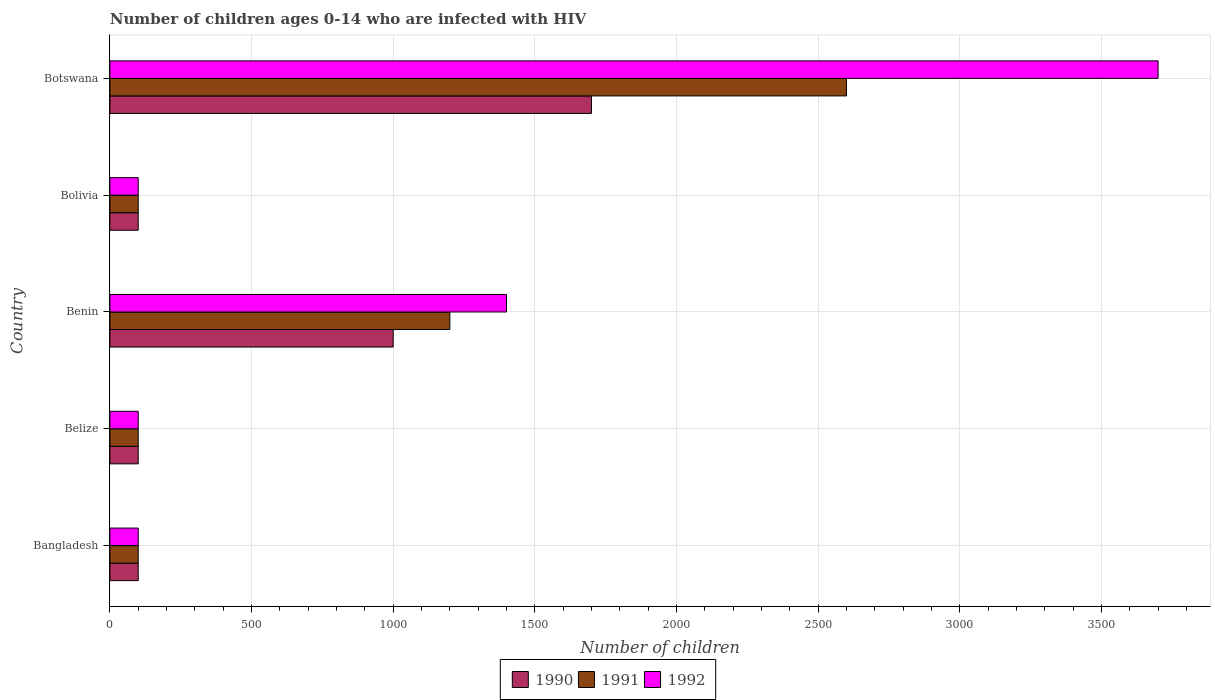How many bars are there on the 4th tick from the top?
Your response must be concise. 3. What is the number of HIV infected children in 1992 in Belize?
Your response must be concise. 100. Across all countries, what is the maximum number of HIV infected children in 1992?
Provide a succinct answer. 3700. Across all countries, what is the minimum number of HIV infected children in 1992?
Ensure brevity in your answer.  100. In which country was the number of HIV infected children in 1992 maximum?
Provide a short and direct response. Botswana. In which country was the number of HIV infected children in 1991 minimum?
Your answer should be very brief. Bangladesh. What is the total number of HIV infected children in 1991 in the graph?
Your answer should be compact. 4100. What is the difference between the number of HIV infected children in 1992 in Bolivia and that in Botswana?
Offer a terse response. -3600. What is the difference between the number of HIV infected children in 1990 in Bangladesh and the number of HIV infected children in 1992 in Belize?
Offer a terse response. 0. What is the average number of HIV infected children in 1990 per country?
Offer a terse response. 600. In how many countries, is the number of HIV infected children in 1990 greater than 2900 ?
Keep it short and to the point. 0. What is the ratio of the number of HIV infected children in 1991 in Belize to that in Benin?
Offer a very short reply. 0.08. Is the difference between the number of HIV infected children in 1990 in Belize and Botswana greater than the difference between the number of HIV infected children in 1991 in Belize and Botswana?
Provide a succinct answer. Yes. What is the difference between the highest and the second highest number of HIV infected children in 1990?
Your answer should be compact. 700. What is the difference between the highest and the lowest number of HIV infected children in 1992?
Provide a short and direct response. 3600. Is the sum of the number of HIV infected children in 1991 in Bangladesh and Bolivia greater than the maximum number of HIV infected children in 1990 across all countries?
Give a very brief answer. No. What does the 1st bar from the bottom in Botswana represents?
Keep it short and to the point. 1990. Is it the case that in every country, the sum of the number of HIV infected children in 1992 and number of HIV infected children in 1990 is greater than the number of HIV infected children in 1991?
Give a very brief answer. Yes. How many bars are there?
Your answer should be compact. 15. What is the difference between two consecutive major ticks on the X-axis?
Give a very brief answer. 500. Where does the legend appear in the graph?
Provide a succinct answer. Bottom center. What is the title of the graph?
Ensure brevity in your answer.  Number of children ages 0-14 who are infected with HIV. Does "1981" appear as one of the legend labels in the graph?
Your answer should be compact. No. What is the label or title of the X-axis?
Give a very brief answer. Number of children. What is the label or title of the Y-axis?
Offer a very short reply. Country. What is the Number of children of 1991 in Belize?
Give a very brief answer. 100. What is the Number of children of 1992 in Belize?
Provide a succinct answer. 100. What is the Number of children in 1990 in Benin?
Your answer should be very brief. 1000. What is the Number of children of 1991 in Benin?
Offer a terse response. 1200. What is the Number of children in 1992 in Benin?
Your answer should be very brief. 1400. What is the Number of children in 1990 in Botswana?
Ensure brevity in your answer.  1700. What is the Number of children in 1991 in Botswana?
Your response must be concise. 2600. What is the Number of children in 1992 in Botswana?
Make the answer very short. 3700. Across all countries, what is the maximum Number of children in 1990?
Your answer should be very brief. 1700. Across all countries, what is the maximum Number of children of 1991?
Offer a very short reply. 2600. Across all countries, what is the maximum Number of children in 1992?
Your answer should be very brief. 3700. Across all countries, what is the minimum Number of children in 1990?
Provide a short and direct response. 100. Across all countries, what is the minimum Number of children of 1991?
Ensure brevity in your answer.  100. Across all countries, what is the minimum Number of children in 1992?
Give a very brief answer. 100. What is the total Number of children in 1990 in the graph?
Make the answer very short. 3000. What is the total Number of children in 1991 in the graph?
Provide a succinct answer. 4100. What is the total Number of children of 1992 in the graph?
Provide a succinct answer. 5400. What is the difference between the Number of children in 1991 in Bangladesh and that in Belize?
Your response must be concise. 0. What is the difference between the Number of children in 1990 in Bangladesh and that in Benin?
Ensure brevity in your answer.  -900. What is the difference between the Number of children in 1991 in Bangladesh and that in Benin?
Ensure brevity in your answer.  -1100. What is the difference between the Number of children in 1992 in Bangladesh and that in Benin?
Your response must be concise. -1300. What is the difference between the Number of children in 1992 in Bangladesh and that in Bolivia?
Ensure brevity in your answer.  0. What is the difference between the Number of children in 1990 in Bangladesh and that in Botswana?
Offer a terse response. -1600. What is the difference between the Number of children in 1991 in Bangladesh and that in Botswana?
Provide a succinct answer. -2500. What is the difference between the Number of children in 1992 in Bangladesh and that in Botswana?
Your answer should be very brief. -3600. What is the difference between the Number of children of 1990 in Belize and that in Benin?
Provide a short and direct response. -900. What is the difference between the Number of children in 1991 in Belize and that in Benin?
Your answer should be very brief. -1100. What is the difference between the Number of children in 1992 in Belize and that in Benin?
Give a very brief answer. -1300. What is the difference between the Number of children of 1992 in Belize and that in Bolivia?
Your answer should be compact. 0. What is the difference between the Number of children in 1990 in Belize and that in Botswana?
Provide a succinct answer. -1600. What is the difference between the Number of children in 1991 in Belize and that in Botswana?
Make the answer very short. -2500. What is the difference between the Number of children in 1992 in Belize and that in Botswana?
Ensure brevity in your answer.  -3600. What is the difference between the Number of children in 1990 in Benin and that in Bolivia?
Your answer should be compact. 900. What is the difference between the Number of children in 1991 in Benin and that in Bolivia?
Give a very brief answer. 1100. What is the difference between the Number of children of 1992 in Benin and that in Bolivia?
Your response must be concise. 1300. What is the difference between the Number of children of 1990 in Benin and that in Botswana?
Provide a short and direct response. -700. What is the difference between the Number of children of 1991 in Benin and that in Botswana?
Give a very brief answer. -1400. What is the difference between the Number of children in 1992 in Benin and that in Botswana?
Offer a very short reply. -2300. What is the difference between the Number of children of 1990 in Bolivia and that in Botswana?
Your response must be concise. -1600. What is the difference between the Number of children in 1991 in Bolivia and that in Botswana?
Ensure brevity in your answer.  -2500. What is the difference between the Number of children in 1992 in Bolivia and that in Botswana?
Your response must be concise. -3600. What is the difference between the Number of children of 1990 in Bangladesh and the Number of children of 1991 in Belize?
Give a very brief answer. 0. What is the difference between the Number of children of 1990 in Bangladesh and the Number of children of 1991 in Benin?
Offer a terse response. -1100. What is the difference between the Number of children in 1990 in Bangladesh and the Number of children in 1992 in Benin?
Offer a terse response. -1300. What is the difference between the Number of children in 1991 in Bangladesh and the Number of children in 1992 in Benin?
Give a very brief answer. -1300. What is the difference between the Number of children of 1990 in Bangladesh and the Number of children of 1991 in Bolivia?
Ensure brevity in your answer.  0. What is the difference between the Number of children of 1990 in Bangladesh and the Number of children of 1992 in Bolivia?
Your answer should be compact. 0. What is the difference between the Number of children of 1990 in Bangladesh and the Number of children of 1991 in Botswana?
Your answer should be very brief. -2500. What is the difference between the Number of children of 1990 in Bangladesh and the Number of children of 1992 in Botswana?
Give a very brief answer. -3600. What is the difference between the Number of children of 1991 in Bangladesh and the Number of children of 1992 in Botswana?
Your answer should be very brief. -3600. What is the difference between the Number of children in 1990 in Belize and the Number of children in 1991 in Benin?
Ensure brevity in your answer.  -1100. What is the difference between the Number of children in 1990 in Belize and the Number of children in 1992 in Benin?
Your answer should be very brief. -1300. What is the difference between the Number of children in 1991 in Belize and the Number of children in 1992 in Benin?
Give a very brief answer. -1300. What is the difference between the Number of children of 1990 in Belize and the Number of children of 1991 in Bolivia?
Make the answer very short. 0. What is the difference between the Number of children of 1991 in Belize and the Number of children of 1992 in Bolivia?
Provide a short and direct response. 0. What is the difference between the Number of children in 1990 in Belize and the Number of children in 1991 in Botswana?
Offer a very short reply. -2500. What is the difference between the Number of children in 1990 in Belize and the Number of children in 1992 in Botswana?
Give a very brief answer. -3600. What is the difference between the Number of children of 1991 in Belize and the Number of children of 1992 in Botswana?
Keep it short and to the point. -3600. What is the difference between the Number of children in 1990 in Benin and the Number of children in 1991 in Bolivia?
Provide a short and direct response. 900. What is the difference between the Number of children in 1990 in Benin and the Number of children in 1992 in Bolivia?
Make the answer very short. 900. What is the difference between the Number of children of 1991 in Benin and the Number of children of 1992 in Bolivia?
Your answer should be very brief. 1100. What is the difference between the Number of children of 1990 in Benin and the Number of children of 1991 in Botswana?
Provide a succinct answer. -1600. What is the difference between the Number of children of 1990 in Benin and the Number of children of 1992 in Botswana?
Your response must be concise. -2700. What is the difference between the Number of children of 1991 in Benin and the Number of children of 1992 in Botswana?
Your response must be concise. -2500. What is the difference between the Number of children in 1990 in Bolivia and the Number of children in 1991 in Botswana?
Give a very brief answer. -2500. What is the difference between the Number of children of 1990 in Bolivia and the Number of children of 1992 in Botswana?
Your answer should be very brief. -3600. What is the difference between the Number of children in 1991 in Bolivia and the Number of children in 1992 in Botswana?
Ensure brevity in your answer.  -3600. What is the average Number of children in 1990 per country?
Give a very brief answer. 600. What is the average Number of children in 1991 per country?
Offer a very short reply. 820. What is the average Number of children of 1992 per country?
Give a very brief answer. 1080. What is the difference between the Number of children in 1990 and Number of children in 1992 in Bangladesh?
Provide a short and direct response. 0. What is the difference between the Number of children of 1991 and Number of children of 1992 in Bangladesh?
Your answer should be compact. 0. What is the difference between the Number of children in 1990 and Number of children in 1991 in Belize?
Provide a succinct answer. 0. What is the difference between the Number of children of 1990 and Number of children of 1992 in Belize?
Offer a very short reply. 0. What is the difference between the Number of children of 1991 and Number of children of 1992 in Belize?
Give a very brief answer. 0. What is the difference between the Number of children of 1990 and Number of children of 1991 in Benin?
Your response must be concise. -200. What is the difference between the Number of children in 1990 and Number of children in 1992 in Benin?
Provide a short and direct response. -400. What is the difference between the Number of children of 1991 and Number of children of 1992 in Benin?
Your answer should be very brief. -200. What is the difference between the Number of children in 1990 and Number of children in 1992 in Bolivia?
Your answer should be compact. 0. What is the difference between the Number of children of 1990 and Number of children of 1991 in Botswana?
Provide a short and direct response. -900. What is the difference between the Number of children in 1990 and Number of children in 1992 in Botswana?
Offer a terse response. -2000. What is the difference between the Number of children of 1991 and Number of children of 1992 in Botswana?
Keep it short and to the point. -1100. What is the ratio of the Number of children in 1992 in Bangladesh to that in Belize?
Ensure brevity in your answer.  1. What is the ratio of the Number of children in 1990 in Bangladesh to that in Benin?
Offer a very short reply. 0.1. What is the ratio of the Number of children of 1991 in Bangladesh to that in Benin?
Offer a terse response. 0.08. What is the ratio of the Number of children of 1992 in Bangladesh to that in Benin?
Your answer should be very brief. 0.07. What is the ratio of the Number of children of 1992 in Bangladesh to that in Bolivia?
Your answer should be compact. 1. What is the ratio of the Number of children in 1990 in Bangladesh to that in Botswana?
Your response must be concise. 0.06. What is the ratio of the Number of children in 1991 in Bangladesh to that in Botswana?
Your answer should be compact. 0.04. What is the ratio of the Number of children in 1992 in Bangladesh to that in Botswana?
Make the answer very short. 0.03. What is the ratio of the Number of children in 1990 in Belize to that in Benin?
Your answer should be very brief. 0.1. What is the ratio of the Number of children of 1991 in Belize to that in Benin?
Keep it short and to the point. 0.08. What is the ratio of the Number of children in 1992 in Belize to that in Benin?
Ensure brevity in your answer.  0.07. What is the ratio of the Number of children in 1992 in Belize to that in Bolivia?
Ensure brevity in your answer.  1. What is the ratio of the Number of children of 1990 in Belize to that in Botswana?
Provide a succinct answer. 0.06. What is the ratio of the Number of children in 1991 in Belize to that in Botswana?
Give a very brief answer. 0.04. What is the ratio of the Number of children of 1992 in Belize to that in Botswana?
Your answer should be very brief. 0.03. What is the ratio of the Number of children of 1990 in Benin to that in Bolivia?
Your answer should be very brief. 10. What is the ratio of the Number of children of 1992 in Benin to that in Bolivia?
Ensure brevity in your answer.  14. What is the ratio of the Number of children of 1990 in Benin to that in Botswana?
Ensure brevity in your answer.  0.59. What is the ratio of the Number of children in 1991 in Benin to that in Botswana?
Offer a terse response. 0.46. What is the ratio of the Number of children in 1992 in Benin to that in Botswana?
Give a very brief answer. 0.38. What is the ratio of the Number of children in 1990 in Bolivia to that in Botswana?
Your answer should be compact. 0.06. What is the ratio of the Number of children of 1991 in Bolivia to that in Botswana?
Provide a short and direct response. 0.04. What is the ratio of the Number of children in 1992 in Bolivia to that in Botswana?
Make the answer very short. 0.03. What is the difference between the highest and the second highest Number of children in 1990?
Offer a very short reply. 700. What is the difference between the highest and the second highest Number of children of 1991?
Make the answer very short. 1400. What is the difference between the highest and the second highest Number of children in 1992?
Your response must be concise. 2300. What is the difference between the highest and the lowest Number of children in 1990?
Your response must be concise. 1600. What is the difference between the highest and the lowest Number of children of 1991?
Your answer should be compact. 2500. What is the difference between the highest and the lowest Number of children of 1992?
Your answer should be very brief. 3600. 